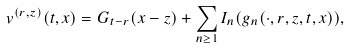Convert formula to latex. <formula><loc_0><loc_0><loc_500><loc_500>v ^ { ( r , z ) } ( t , x ) = G _ { t - r } ( x - z ) + \sum _ { n \geq 1 } I _ { n } ( g _ { n } ( \cdot , r , z , t , x ) ) ,</formula> 